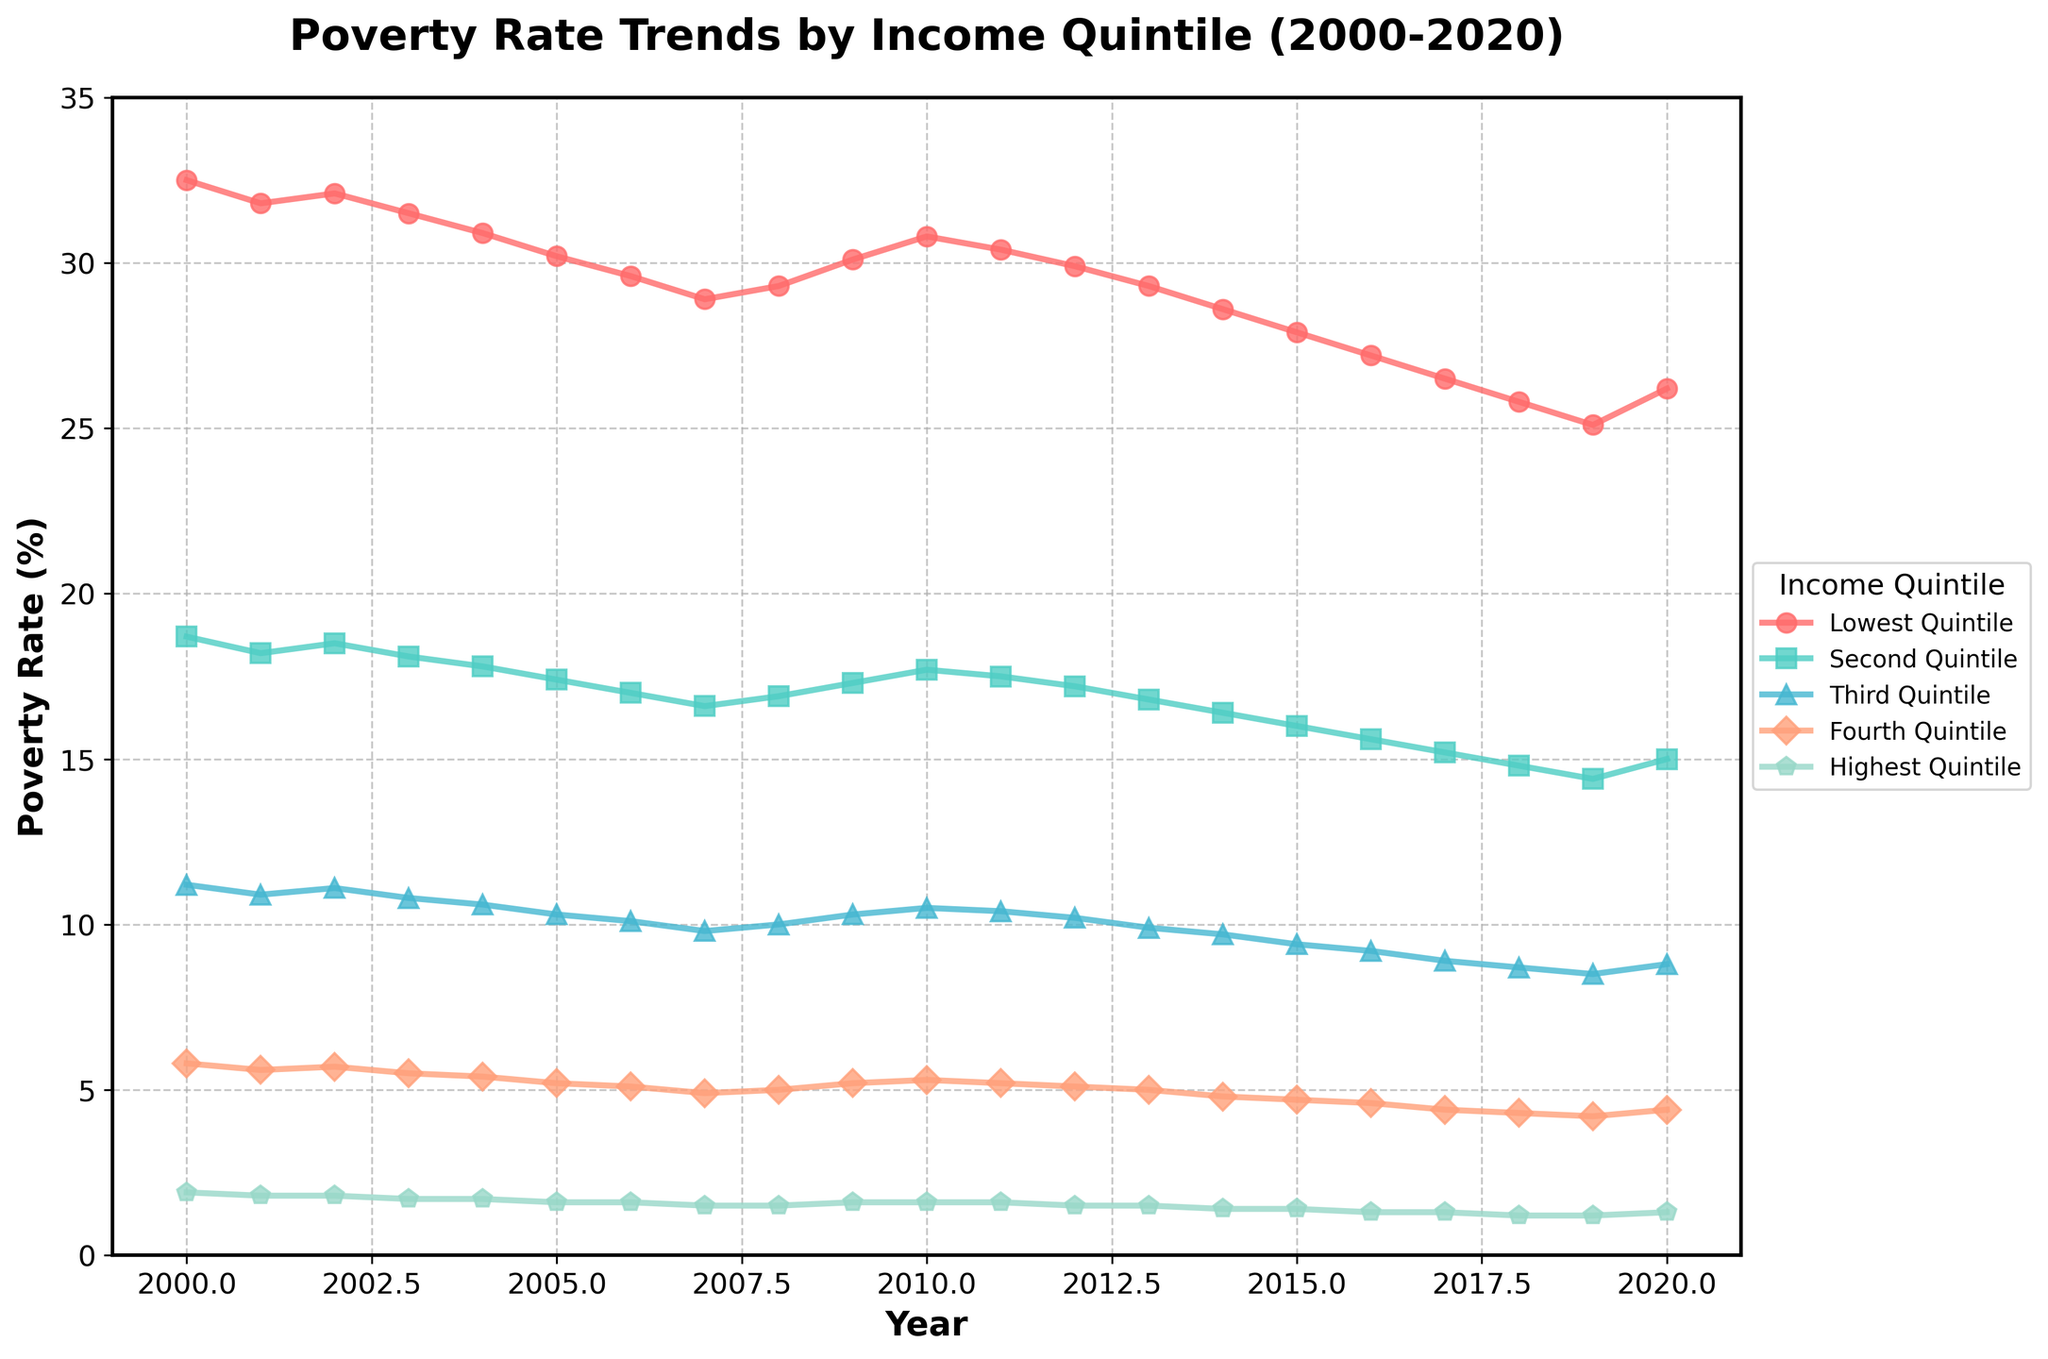Which income quintile shows the highest poverty rate throughout most of the years? By examining the figure, we can see that the line representing the lowest quintile is consistently at the highest position, indicating the highest poverty rate.
Answer: Lowest quintile How did the poverty rate of the lowest quintile change from 2000 to 2020? In the figure, the poverty rate for the lowest quintile starts at 32.5% in 2000 and ends at 26.2% in 2020. The change is 32.5 - 26.2 = 6.3%.
Answer: Decreased by 6.3% Which year shows the smallest difference between the highest and lowest quintile poverty rates? To answer this, we need to find the year where the difference between the highest and lowest quintiles is the smallest. The differences are smallest in the later years (e.g., 2020 with 26.2% - 1.3% = 24.9%).
Answer: 2018 and 2019 What is the trend of the poverty rate for the second quintile over the years? Observing the figure, the line for the second quintile generally shows a decreasing trend from 18.7% in 2000 to 15.0% in 2020.
Answer: Decreasing In which years do the lines for the lowest and third quintiles intersect? The lines for the lowest and third quintiles never intersect in the figure; the lowest quintile remains above the third quintile throughout the years.
Answer: Never intersect By how much did the poverty rate for the fourth quintile decrease between 2000 and 2020? The figure shows the poverty rate for the fourth quintile decreased from 5.8% in 2000 to 4.4% in 2020. The decrease is 5.8% - 4.4% = 1.4%.
Answer: 1.4% Which income quintile had a poverty rate closest to 10% in 2010? Observing the figure, the third quintile had a poverty rate of 10.5% in the year 2010.
Answer: Third quintile Compare the poverty rate change trends between the first and last quintile from 2000 to 2020. By looking at the figure, the lowest quintile shows a significant decrease from 32.5% to 26.2%, while the highest quintile remains relatively stable, slightly decreasing from 1.9% to 1.3%.
Answer: Lowest quintile decreased significantly, highest quintile remained stable 